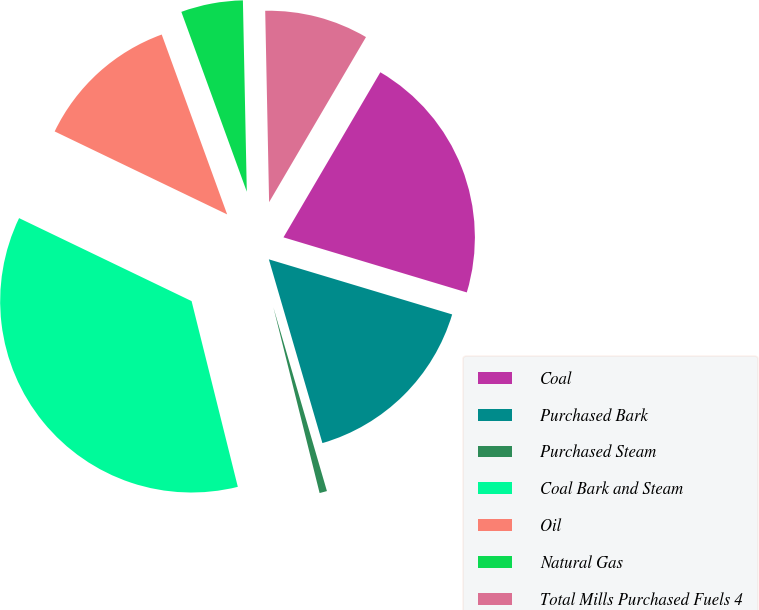Convert chart. <chart><loc_0><loc_0><loc_500><loc_500><pie_chart><fcel>Coal<fcel>Purchased Bark<fcel>Purchased Steam<fcel>Coal Bark and Steam<fcel>Oil<fcel>Natural Gas<fcel>Total Mills Purchased Fuels 4<nl><fcel>21.2%<fcel>15.84%<fcel>0.63%<fcel>36.02%<fcel>12.31%<fcel>5.23%<fcel>8.77%<nl></chart> 